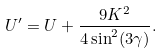Convert formula to latex. <formula><loc_0><loc_0><loc_500><loc_500>U ^ { \prime } = U + \frac { 9 K ^ { 2 } } { 4 \sin ^ { 2 } ( 3 \gamma ) } .</formula> 